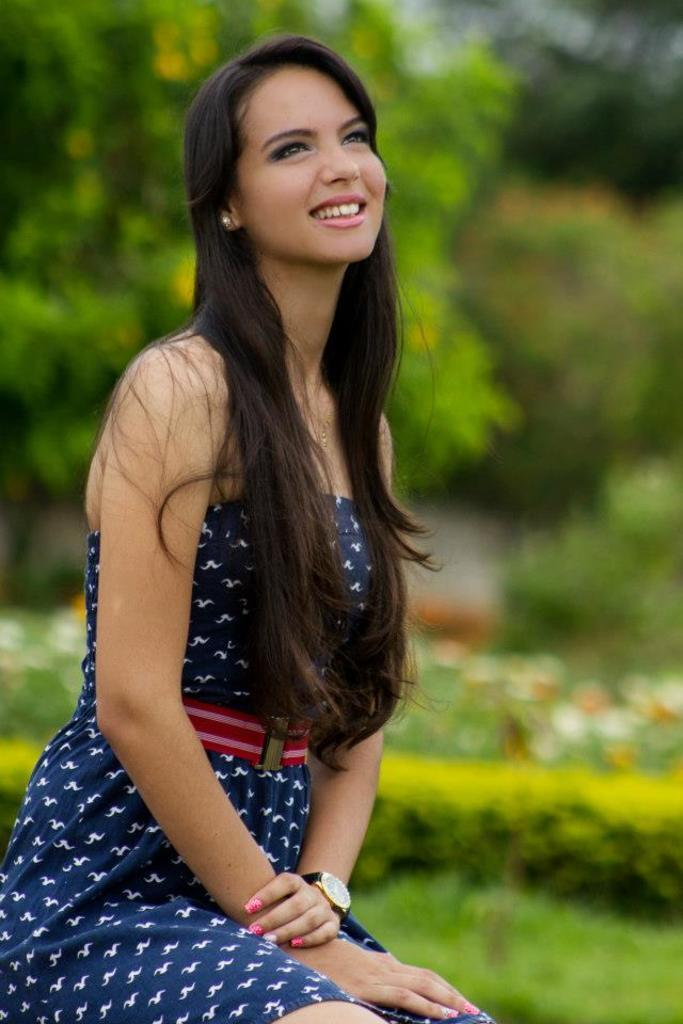Who is present in the image? There is a woman in the image. What is the woman doing in the image? The woman is sitting. What is the woman's facial expression in the image? The woman is smiling. What can be seen in the background of the image? There are trees, flowers, ground, and bushes visible in the background of the image. How many elbows can be seen in the image? There are no elbows visible in the image, as it only features a woman sitting and smiling. What type of match is being played in the background of the image? There is no match being played in the background of the image; it only features trees, flowers, ground, and bushes. 